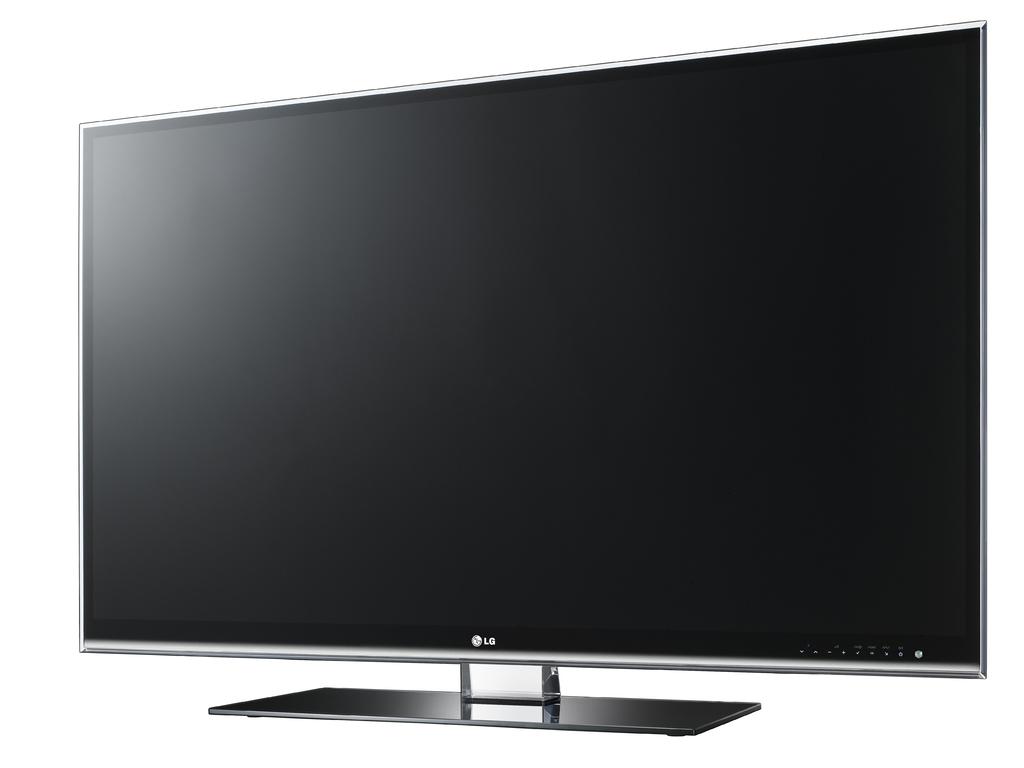Is this made by lg?
Ensure brevity in your answer.  Yes. 